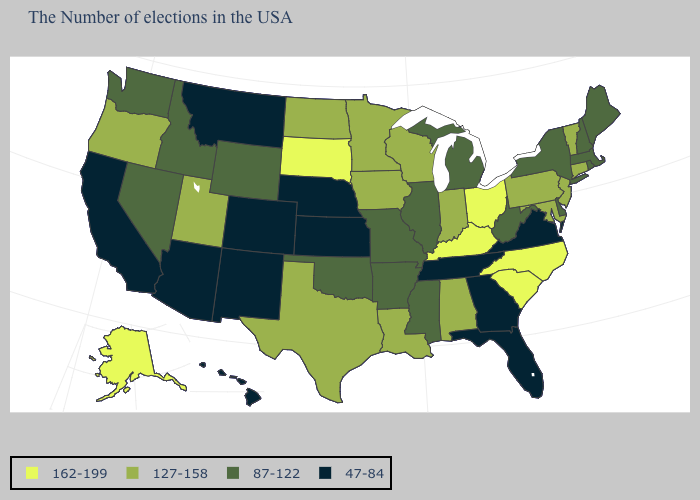What is the value of Maine?
Quick response, please. 87-122. Which states hav the highest value in the West?
Answer briefly. Alaska. What is the value of Maine?
Answer briefly. 87-122. Which states have the highest value in the USA?
Concise answer only. North Carolina, South Carolina, Ohio, Kentucky, South Dakota, Alaska. What is the value of Pennsylvania?
Answer briefly. 127-158. Is the legend a continuous bar?
Short answer required. No. What is the lowest value in the USA?
Keep it brief. 47-84. What is the value of Alabama?
Write a very short answer. 127-158. Is the legend a continuous bar?
Keep it brief. No. What is the value of Arkansas?
Answer briefly. 87-122. Name the states that have a value in the range 162-199?
Write a very short answer. North Carolina, South Carolina, Ohio, Kentucky, South Dakota, Alaska. What is the lowest value in states that border Delaware?
Give a very brief answer. 127-158. What is the value of Nebraska?
Short answer required. 47-84. Is the legend a continuous bar?
Short answer required. No. Does Hawaii have the lowest value in the USA?
Be succinct. Yes. 